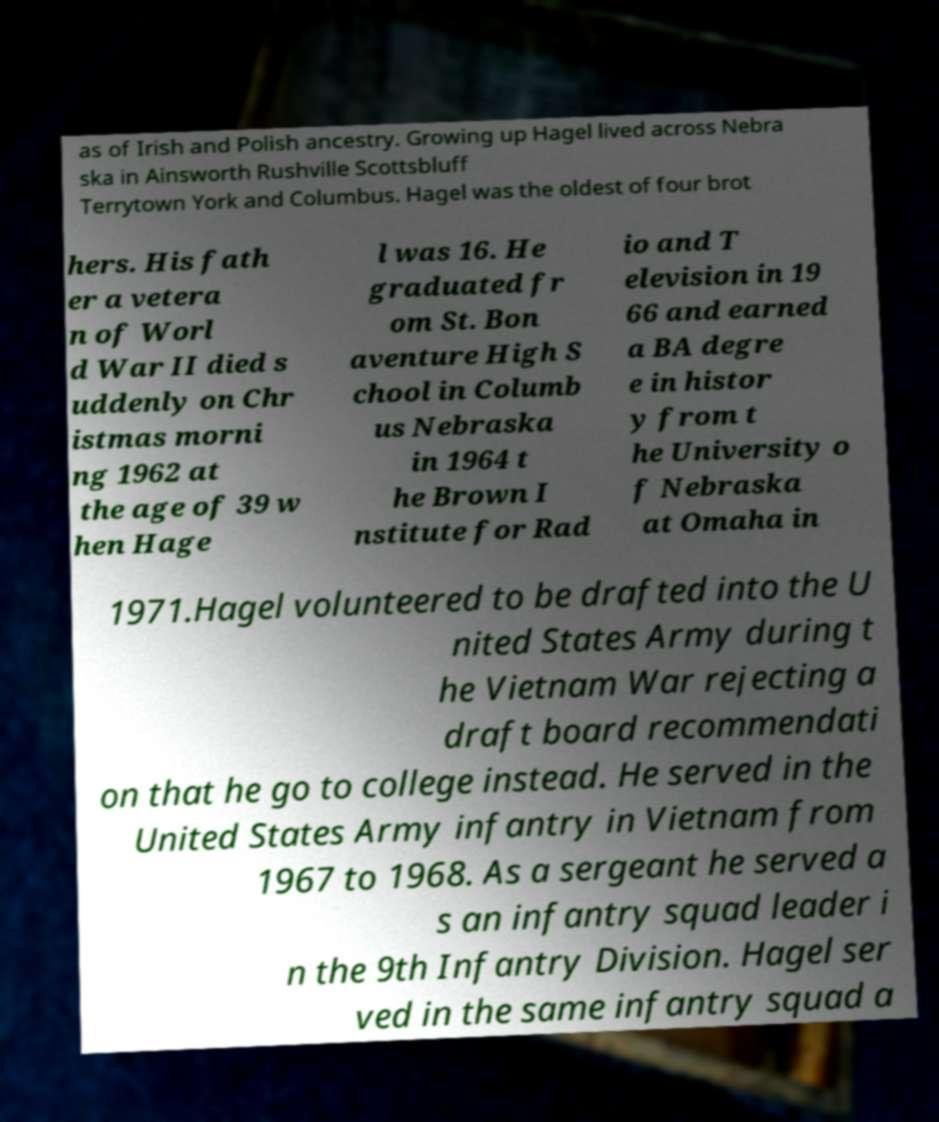Please identify and transcribe the text found in this image. as of Irish and Polish ancestry. Growing up Hagel lived across Nebra ska in Ainsworth Rushville Scottsbluff Terrytown York and Columbus. Hagel was the oldest of four brot hers. His fath er a vetera n of Worl d War II died s uddenly on Chr istmas morni ng 1962 at the age of 39 w hen Hage l was 16. He graduated fr om St. Bon aventure High S chool in Columb us Nebraska in 1964 t he Brown I nstitute for Rad io and T elevision in 19 66 and earned a BA degre e in histor y from t he University o f Nebraska at Omaha in 1971.Hagel volunteered to be drafted into the U nited States Army during t he Vietnam War rejecting a draft board recommendati on that he go to college instead. He served in the United States Army infantry in Vietnam from 1967 to 1968. As a sergeant he served a s an infantry squad leader i n the 9th Infantry Division. Hagel ser ved in the same infantry squad a 